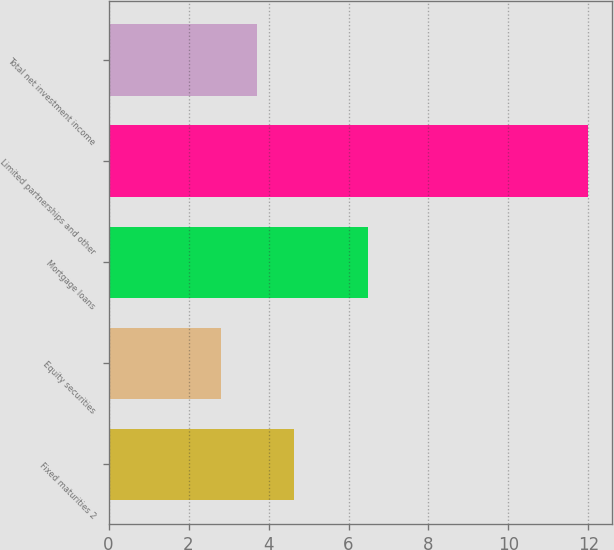Convert chart. <chart><loc_0><loc_0><loc_500><loc_500><bar_chart><fcel>Fixed maturities 2<fcel>Equity securities<fcel>Mortgage loans<fcel>Limited partnerships and other<fcel>Total net investment income<nl><fcel>4.64<fcel>2.8<fcel>6.48<fcel>12<fcel>3.72<nl></chart> 